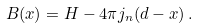<formula> <loc_0><loc_0><loc_500><loc_500>B ( x ) = H - 4 \pi j _ { n } ( d - x ) \, .</formula> 